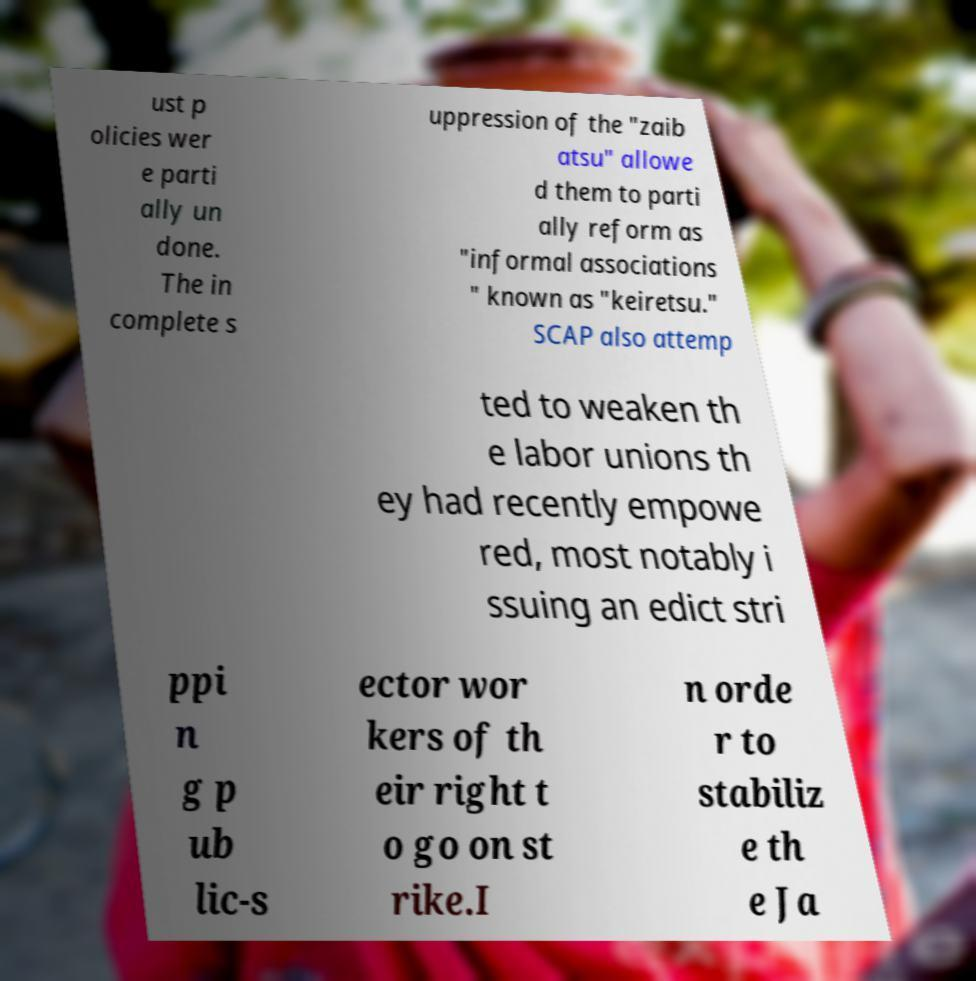Could you extract and type out the text from this image? ust p olicies wer e parti ally un done. The in complete s uppression of the "zaib atsu" allowe d them to parti ally reform as "informal associations " known as "keiretsu." SCAP also attemp ted to weaken th e labor unions th ey had recently empowe red, most notably i ssuing an edict stri ppi n g p ub lic-s ector wor kers of th eir right t o go on st rike.I n orde r to stabiliz e th e Ja 